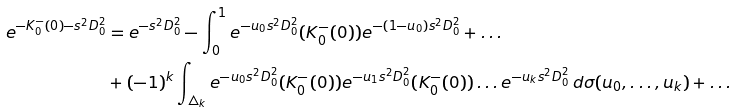<formula> <loc_0><loc_0><loc_500><loc_500>e ^ { - K _ { 0 } ^ { - } ( 0 ) - s ^ { 2 } D _ { 0 } ^ { 2 } } & = e ^ { - s ^ { 2 } D _ { 0 } ^ { 2 } } - \int _ { 0 } ^ { 1 } e ^ { - u _ { 0 } s ^ { 2 } D _ { 0 } ^ { 2 } } ( K _ { 0 } ^ { - } ( 0 ) ) e ^ { - ( 1 - u _ { 0 } ) s ^ { 2 } D _ { 0 } ^ { 2 } } + \dots \\ & + ( - 1 ) ^ { k } \int _ { \triangle _ { k } } e ^ { - u _ { 0 } s ^ { 2 } D _ { 0 } ^ { 2 } } ( K _ { 0 } ^ { - } ( 0 ) ) e ^ { - u _ { 1 } s ^ { 2 } D _ { 0 } ^ { 2 } } ( K _ { 0 } ^ { - } ( 0 ) ) \dots e ^ { - u _ { k } s ^ { 2 } D _ { 0 } ^ { 2 } } \, d \sigma ( u _ { 0 } , \dots , u _ { k } ) + \dots</formula> 